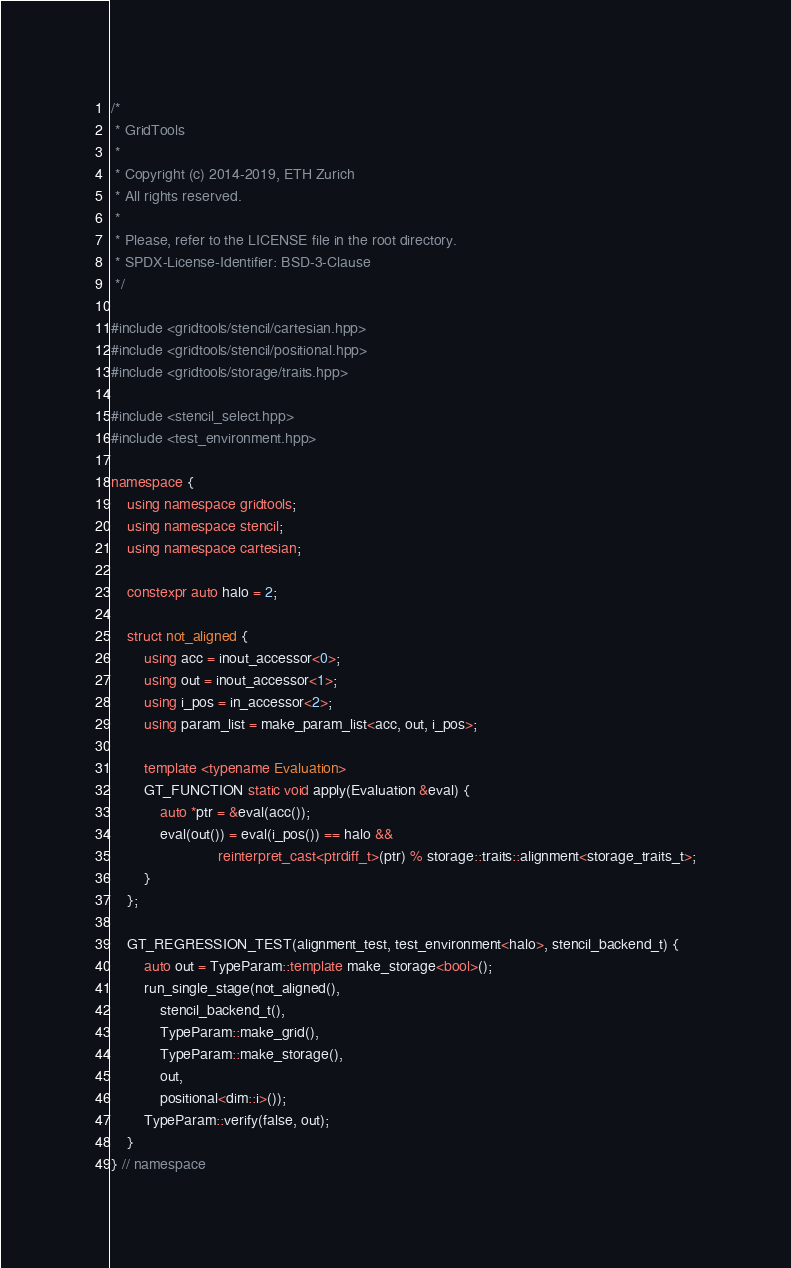<code> <loc_0><loc_0><loc_500><loc_500><_C++_>/*
 * GridTools
 *
 * Copyright (c) 2014-2019, ETH Zurich
 * All rights reserved.
 *
 * Please, refer to the LICENSE file in the root directory.
 * SPDX-License-Identifier: BSD-3-Clause
 */

#include <gridtools/stencil/cartesian.hpp>
#include <gridtools/stencil/positional.hpp>
#include <gridtools/storage/traits.hpp>

#include <stencil_select.hpp>
#include <test_environment.hpp>

namespace {
    using namespace gridtools;
    using namespace stencil;
    using namespace cartesian;

    constexpr auto halo = 2;

    struct not_aligned {
        using acc = inout_accessor<0>;
        using out = inout_accessor<1>;
        using i_pos = in_accessor<2>;
        using param_list = make_param_list<acc, out, i_pos>;

        template <typename Evaluation>
        GT_FUNCTION static void apply(Evaluation &eval) {
            auto *ptr = &eval(acc());
            eval(out()) = eval(i_pos()) == halo &&
                          reinterpret_cast<ptrdiff_t>(ptr) % storage::traits::alignment<storage_traits_t>;
        }
    };

    GT_REGRESSION_TEST(alignment_test, test_environment<halo>, stencil_backend_t) {
        auto out = TypeParam::template make_storage<bool>();
        run_single_stage(not_aligned(),
            stencil_backend_t(),
            TypeParam::make_grid(),
            TypeParam::make_storage(),
            out,
            positional<dim::i>());
        TypeParam::verify(false, out);
    }
} // namespace
</code> 